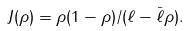Convert formula to latex. <formula><loc_0><loc_0><loc_500><loc_500>J ( \rho ) = \rho ( 1 - \rho ) / ( \ell - \bar { \ell } \rho ) .</formula> 